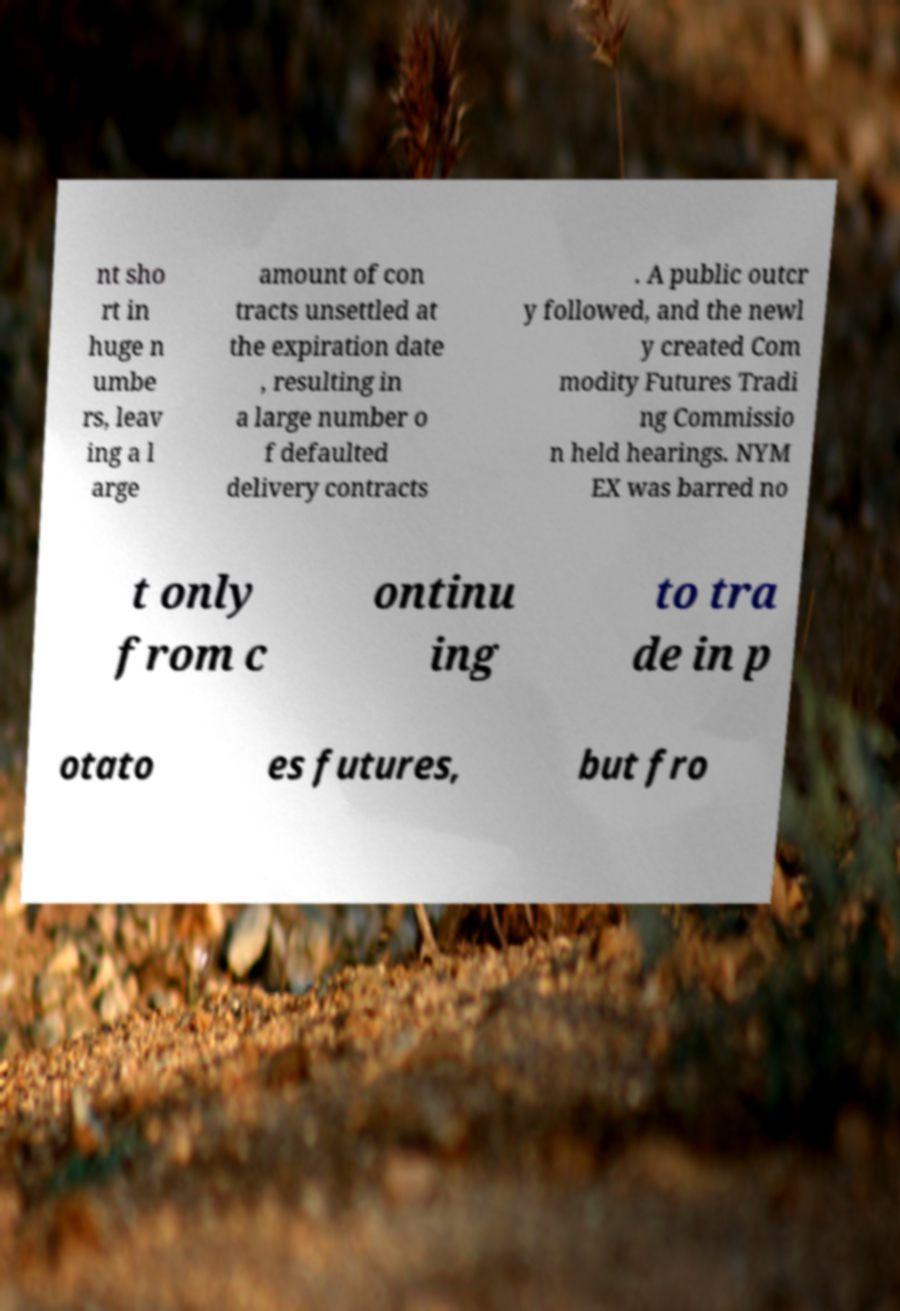I need the written content from this picture converted into text. Can you do that? nt sho rt in huge n umbe rs, leav ing a l arge amount of con tracts unsettled at the expiration date , resulting in a large number o f defaulted delivery contracts . A public outcr y followed, and the newl y created Com modity Futures Tradi ng Commissio n held hearings. NYM EX was barred no t only from c ontinu ing to tra de in p otato es futures, but fro 